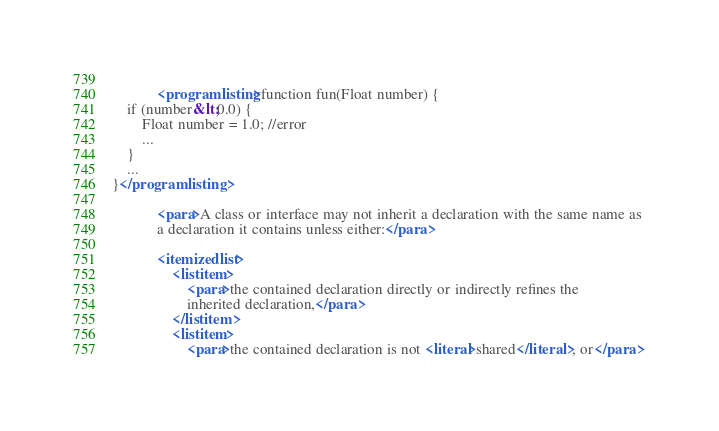Convert code to text. <code><loc_0><loc_0><loc_500><loc_500><_XML_>            
            <programlisting>function fun(Float number) {
    if (number&lt;0.0) {
        Float number = 1.0; //error
        ...
    }
    ...
}</programlisting>
            
            <para>A class or interface may not inherit a declaration with the same name as 
            a declaration it contains unless either:</para>
                
            <itemizedlist>
                <listitem>
                    <para>the contained declaration directly or indirectly refines the 
                    inherited declaration,</para>
                </listitem>
                <listitem>
                    <para>the contained declaration is not <literal>shared</literal>, or</para></code> 